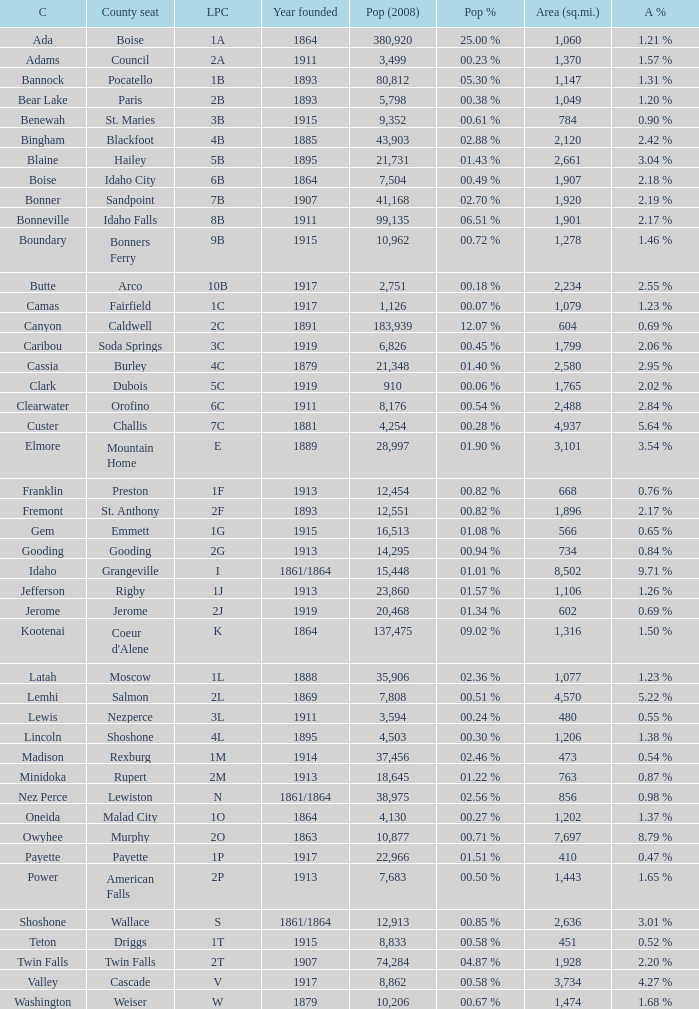What is the license plate code for the country with an area of 784? 3B. 